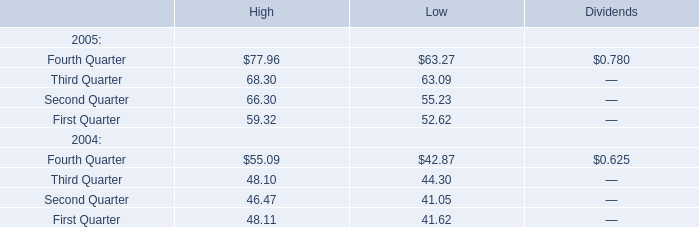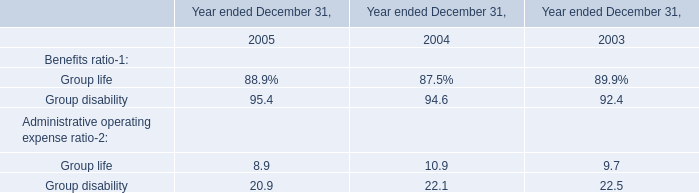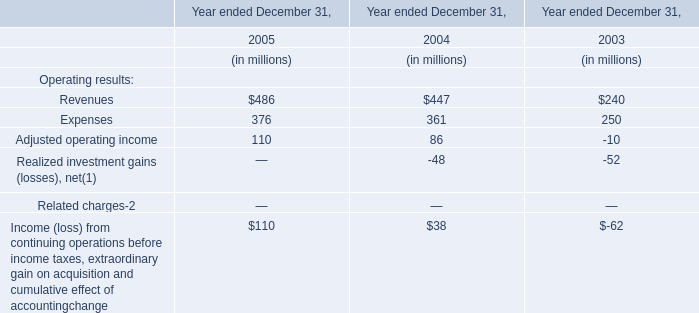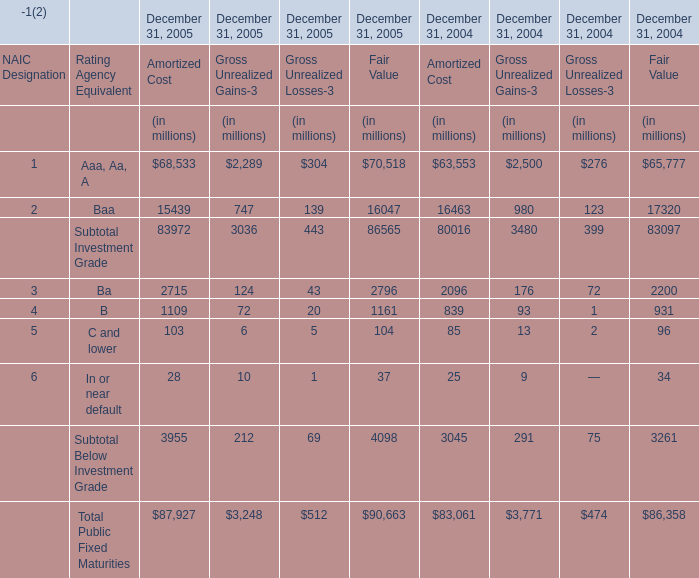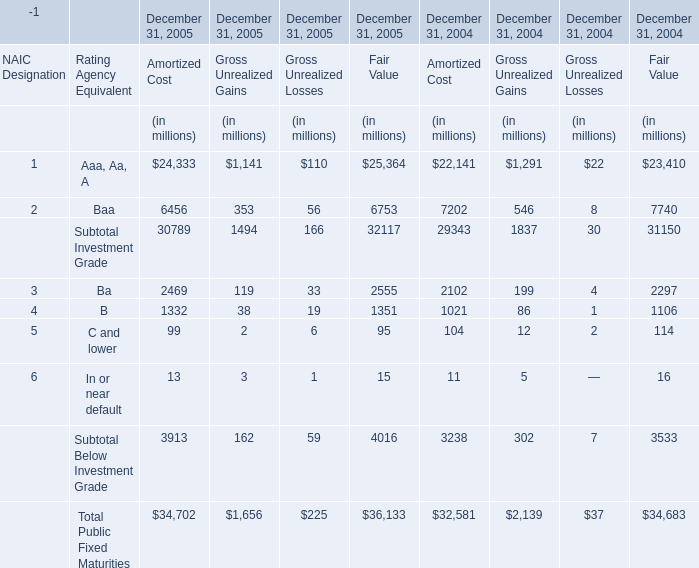What is the sum of the B in the years where Ba for Fair Value is greater than 30? (in million) 
Computations: (((1332 + 38) + 19) + 1351)
Answer: 2740.0. 